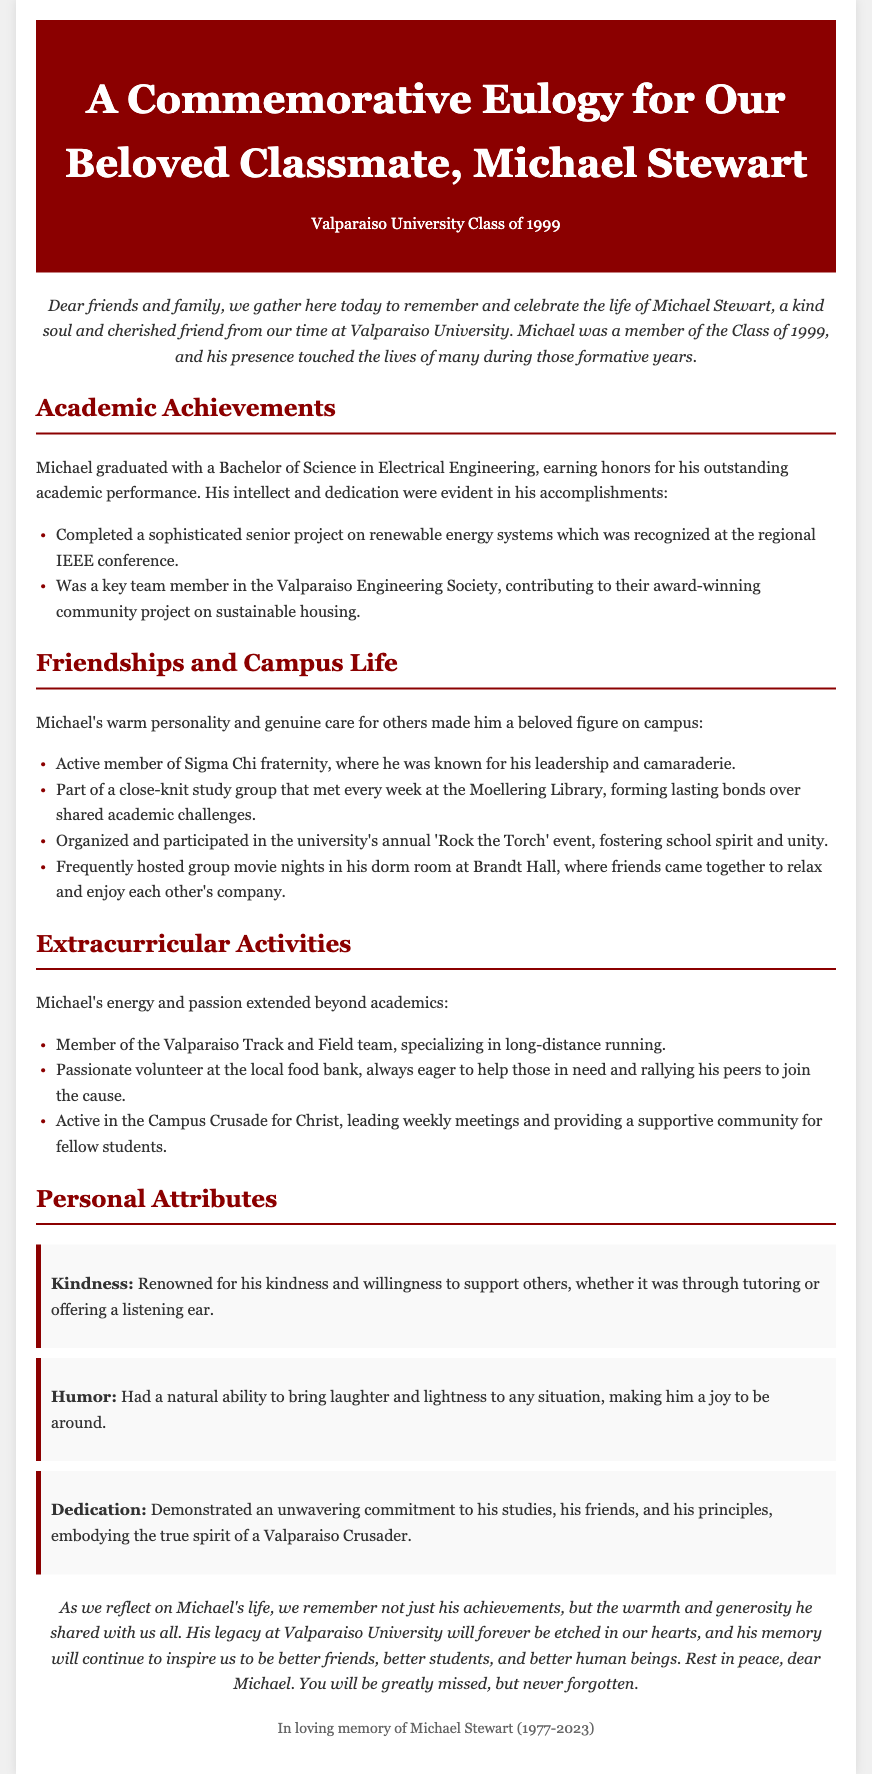what degree did Michael Stewart earn? Michael Stewart graduated with a Bachelor of Science in Electrical Engineering.
Answer: Bachelor of Science in Electrical Engineering what was the title of Michael's senior project? The senior project on renewable energy systems was completed by Michael and recognized at the regional IEEE conference.
Answer: renewable energy systems in which fraternity was Michael an active member? Michael was an active member of Sigma Chi fraternity.
Answer: Sigma Chi what extracurricular activity did Michael participate in that involved helping others? Michael was a passionate volunteer at the local food bank, always eager to help those in need.
Answer: local food bank how many years did Michael live from birth to death? Michael was born in 1977 and passed away in 2023. Therefore, he lived for 46 years.
Answer: 46 years which annual event did Michael organize and participate in? Michael organized and participated in the university's annual 'Rock the Torch' event.
Answer: 'Rock the Torch' what attribute is associated with Michael's ability to support others? Michael was renowned for his kindness and willingness to support others.
Answer: kindness what sports team did Michael belong to? Michael was a member of the Valparaiso Track and Field team.
Answer: Valparaiso Track and Field team 